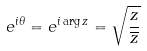Convert formula to latex. <formula><loc_0><loc_0><loc_500><loc_500>e ^ { i \theta } = e ^ { i \arg z } = \sqrt { \frac { z } { \overline { z } } }</formula> 